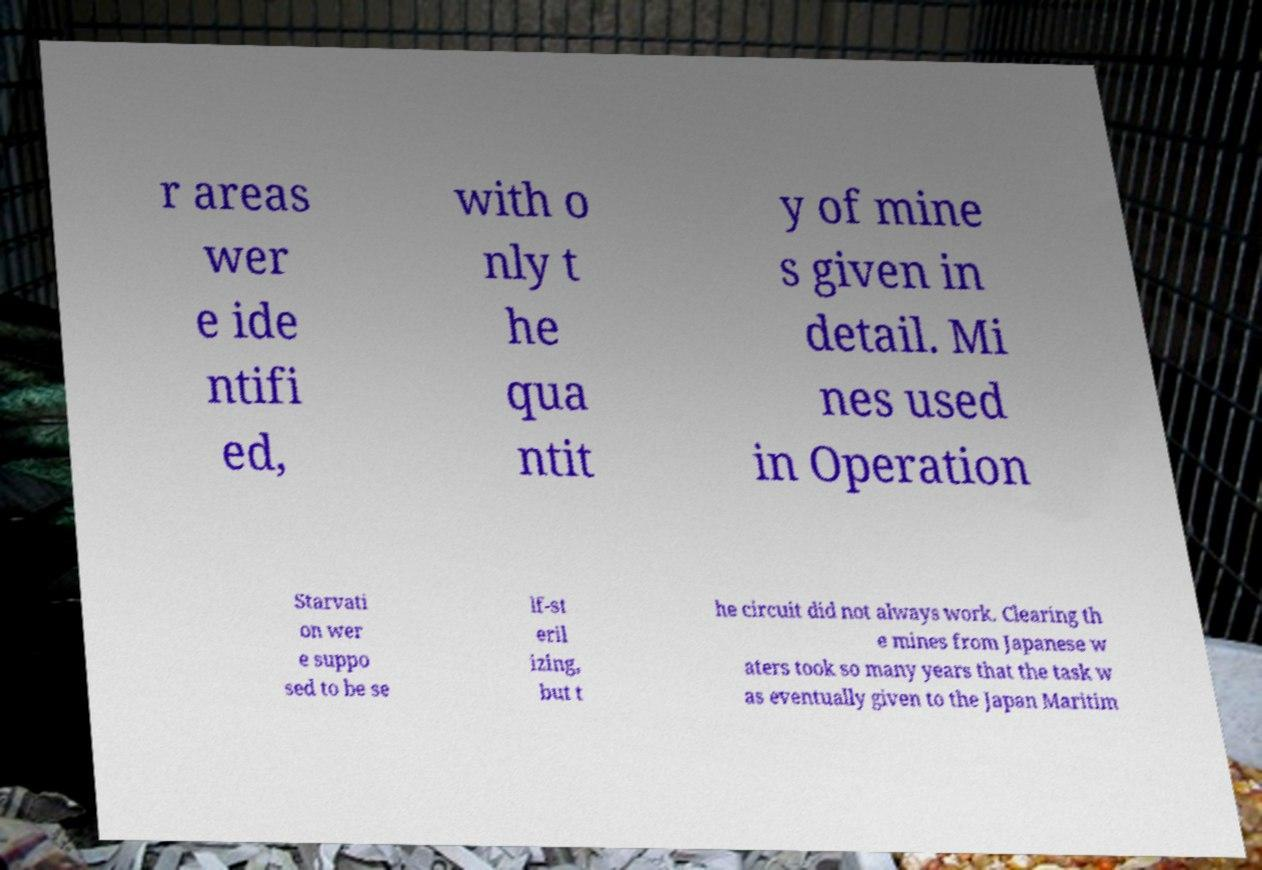I need the written content from this picture converted into text. Can you do that? r areas wer e ide ntifi ed, with o nly t he qua ntit y of mine s given in detail. Mi nes used in Operation Starvati on wer e suppo sed to be se lf-st eril izing, but t he circuit did not always work. Clearing th e mines from Japanese w aters took so many years that the task w as eventually given to the Japan Maritim 